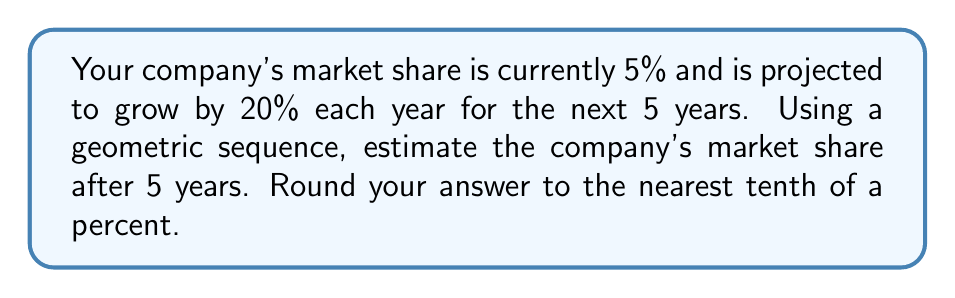Give your solution to this math problem. Let's approach this step-by-step:

1) The initial market share is 5%, which we'll denote as $a_1 = 5\%$.

2) The common ratio for the geometric sequence is 1.20, as the market share grows by 20% (or multiplies by 1.20) each year.

3) We want to find the 5th term in this geometric sequence, which represents the market share after 5 years.

4) The formula for the nth term of a geometric sequence is:

   $a_n = a_1 \cdot r^{n-1}$

   Where $a_n$ is the nth term, $a_1$ is the first term, $r$ is the common ratio, and $n$ is the position of the term.

5) Plugging in our values:

   $a_5 = 5 \cdot 1.20^{5-1} = 5 \cdot 1.20^4$

6) Calculate:

   $a_5 = 5 \cdot (2.0736) = 10.368\%$

7) Rounding to the nearest tenth of a percent:

   $a_5 \approx 10.4\%$
Answer: 10.4% 